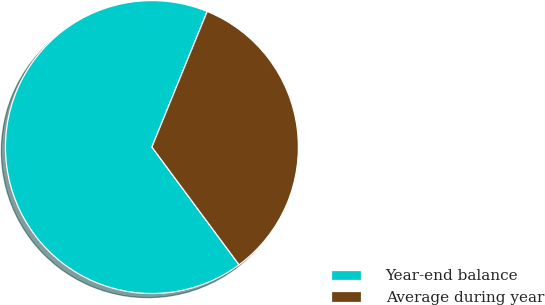Convert chart to OTSL. <chart><loc_0><loc_0><loc_500><loc_500><pie_chart><fcel>Year-end balance<fcel>Average during year<nl><fcel>66.3%<fcel>33.7%<nl></chart> 